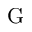<formula> <loc_0><loc_0><loc_500><loc_500>G</formula> 